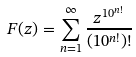Convert formula to latex. <formula><loc_0><loc_0><loc_500><loc_500>F ( z ) = \sum _ { n = 1 } ^ { \infty } \frac { z ^ { 1 0 ^ { n ! } } } { ( 1 0 ^ { n ! } ) ! }</formula> 